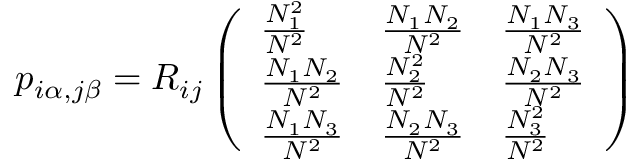<formula> <loc_0><loc_0><loc_500><loc_500>p _ { i \alpha , j \beta } = R _ { i j } \left ( \begin{array} { l l l } { \frac { N _ { 1 } ^ { 2 } } { N ^ { 2 } } } & { \frac { N _ { 1 } N _ { 2 } } { N ^ { 2 } } } & { \frac { N _ { 1 } N _ { 3 } } { N ^ { 2 } } } \\ { \frac { N _ { 1 } N _ { 2 } } { N ^ { 2 } } } & { \frac { N _ { 2 } ^ { 2 } } { N ^ { 2 } } } & { \frac { N _ { 2 } N _ { 3 } } { N ^ { 2 } } } \\ { \frac { N _ { 1 } N _ { 3 } } { N ^ { 2 } } } & { \frac { N _ { 2 } N _ { 3 } } { N ^ { 2 } } } & { \frac { N _ { 3 } ^ { 2 } } { N ^ { 2 } } } \end{array} \right )</formula> 